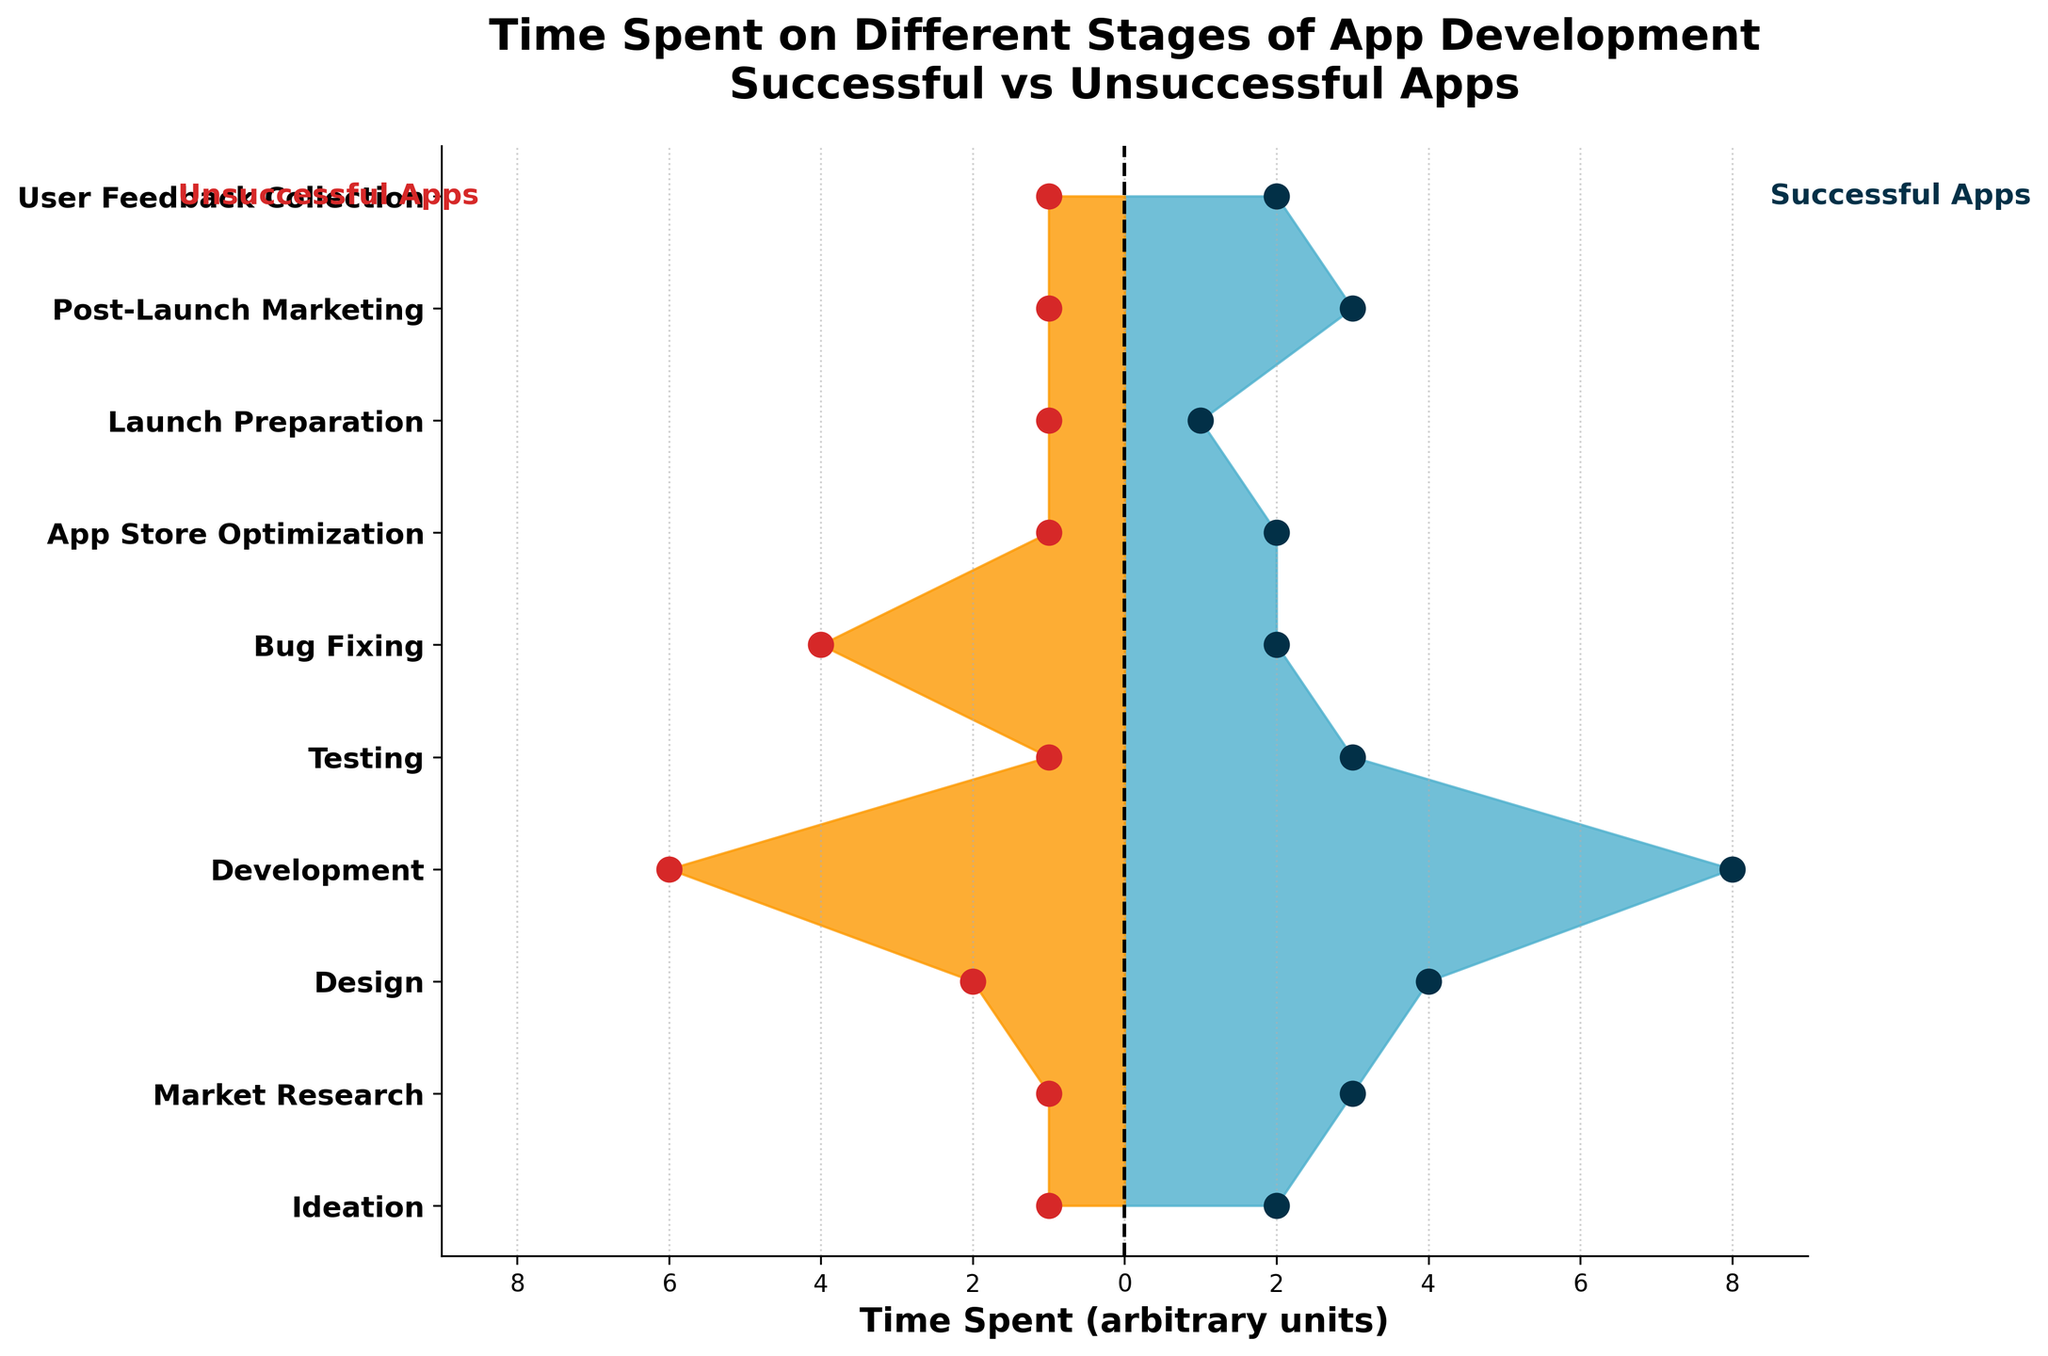how many stages are compared in the plot? There are 10 rows in the data, each corresponding to a unique stage of app development. This means the plot compares 10 stages.
Answer: 10 What is the title of the plot? The title is displayed at the top of the plot and reads: "Time Spent on Different Stages of App Development\nSuccessful vs Unsuccessful Apps."
Answer: Time Spent on Different Stages of App Development\nSuccessful vs Unsuccessful Apps Which stage shows the greatest time spent by successful apps? The stage with the highest value for "Successful Apps" is the Development stage, which has a time spent value of 8.
Answer: Development What is the difference in time spent on Development between successful and unsuccessful apps? The Development stage has 8 units of time spent for successful apps and 6 units for unsuccessful apps. The difference is 8 - 6 = 2.
Answer: 2 Which stages have equal time spent for both successful and unsuccessful apps? By examining the filled areas, the only stage where both successful and unsuccessful apps have the same time spent (value of 1) is Launch Preparation.
Answer: Launch Preparation What is the total time spent by unsuccessful apps on Testing and Bug Fixing? The values for "Unsuccessful Apps" in the Testing and Bug Fixing stages are 1 and 4, respectively. The total is 1 + 4 = 5.
Answer: 5 During which stage do unsuccessful apps spend more time than successful apps? Unsuccessful apps spend more time than successful apps in the Bug Fixing stage, where the values are 4 and 2, respectively.
Answer: Bug Fixing Comparing the time spent on Market Research and User Feedback Collection for successful apps, which stage takes longer? By looking at the values for "Successful Apps," Market Research has a value of 3, while User Feedback Collection has a value of 2. Market Research takes longer.
Answer: Market Research What is the average time spent by unsuccessful apps across all stages? The sum of the times spent by unsuccessful apps across all stages is 1+1+2+6+1+4+1+1+1+1 = 19. There are 10 stages, so the average is 19/10 = 1.9.
Answer: 1.9 Which stage shows an equal amount of time spent by successful apps across two stages? Both Ideation and App Store Optimization have time spent values of 2 for successful apps.
Answer: Ideation, App Store Optimization 